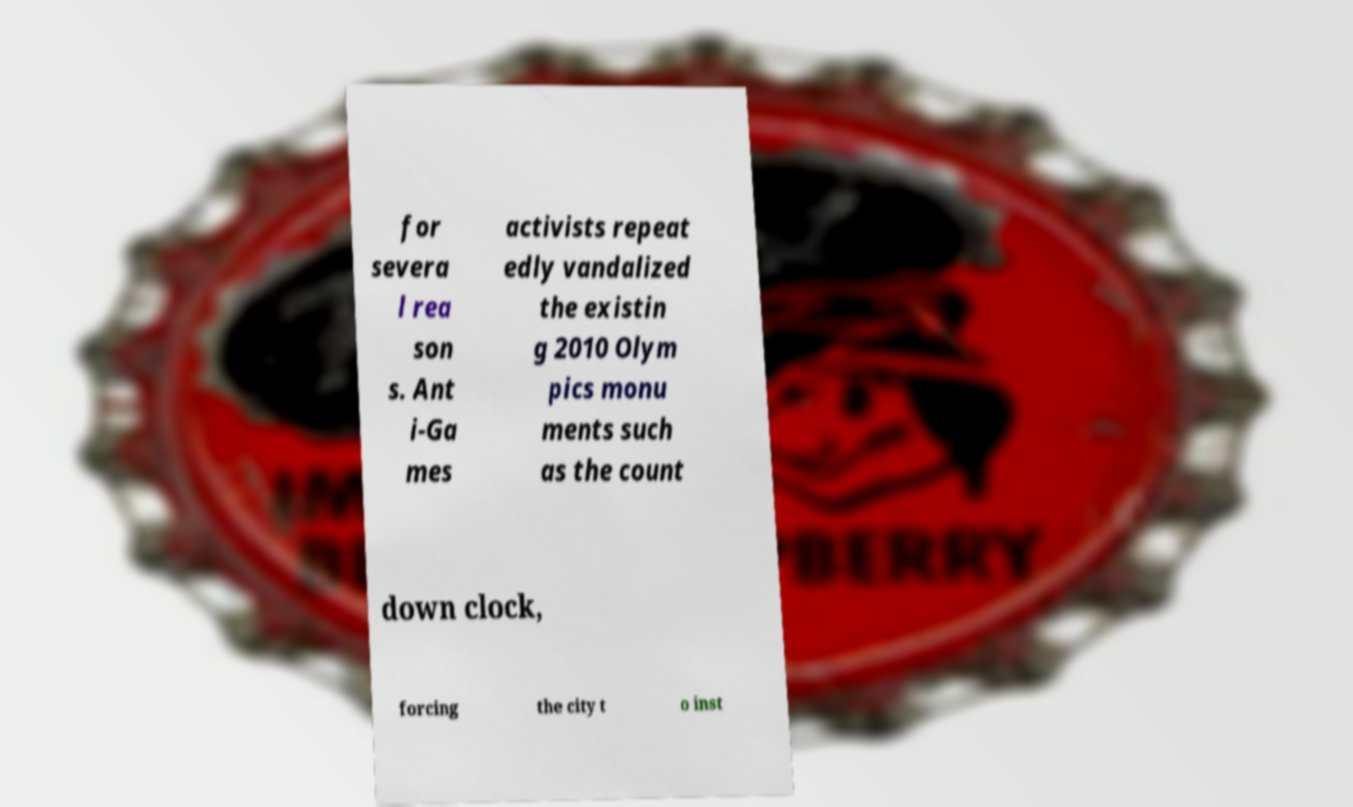Please identify and transcribe the text found in this image. for severa l rea son s. Ant i-Ga mes activists repeat edly vandalized the existin g 2010 Olym pics monu ments such as the count down clock, forcing the city t o inst 